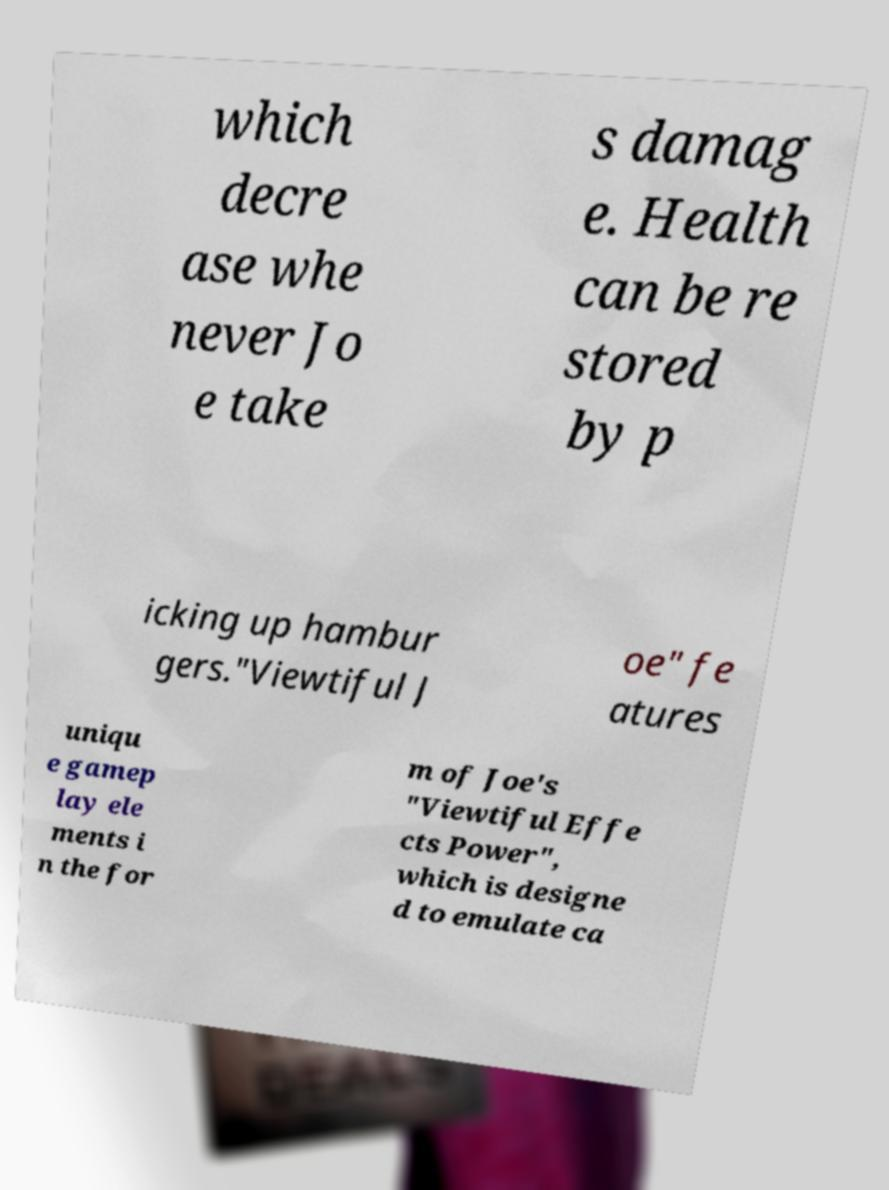I need the written content from this picture converted into text. Can you do that? which decre ase whe never Jo e take s damag e. Health can be re stored by p icking up hambur gers."Viewtiful J oe" fe atures uniqu e gamep lay ele ments i n the for m of Joe's "Viewtiful Effe cts Power", which is designe d to emulate ca 